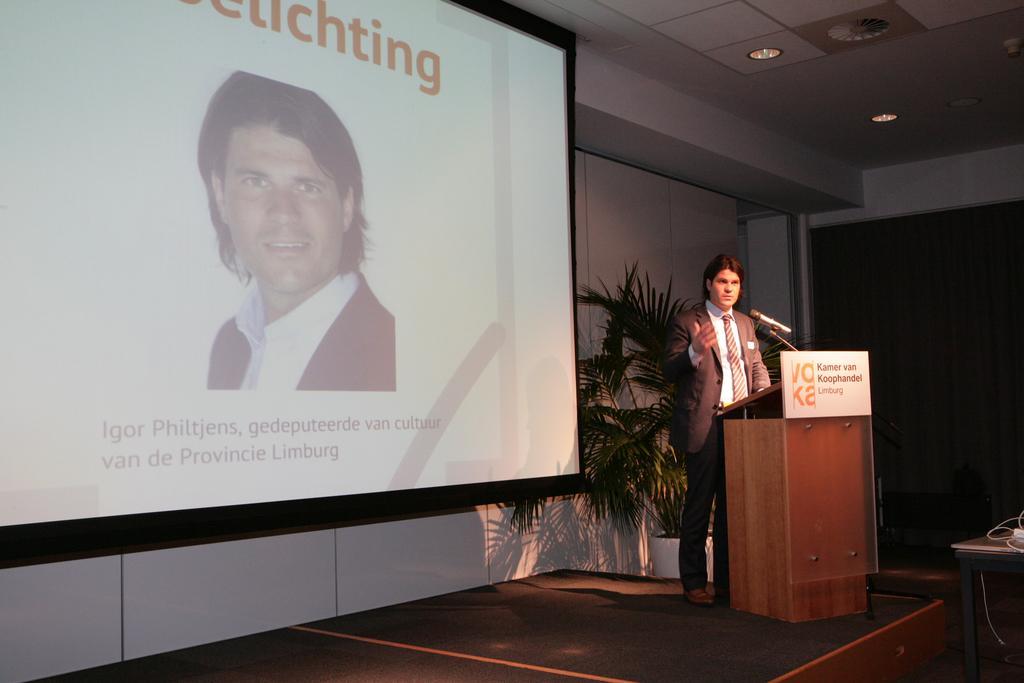Could you give a brief overview of what you see in this image? On the right side of the image we can see person standing at the desk. In the background we can see houseplant, curtain, door, screen and wall. 